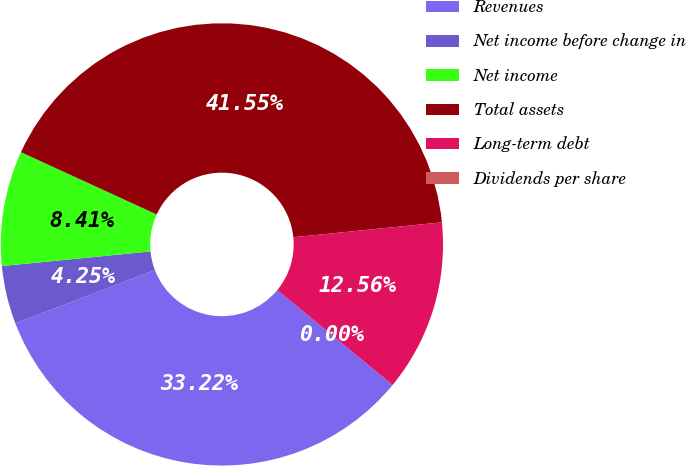Convert chart. <chart><loc_0><loc_0><loc_500><loc_500><pie_chart><fcel>Revenues<fcel>Net income before change in<fcel>Net income<fcel>Total assets<fcel>Long-term debt<fcel>Dividends per share<nl><fcel>33.22%<fcel>4.25%<fcel>8.41%<fcel>41.55%<fcel>12.56%<fcel>0.0%<nl></chart> 